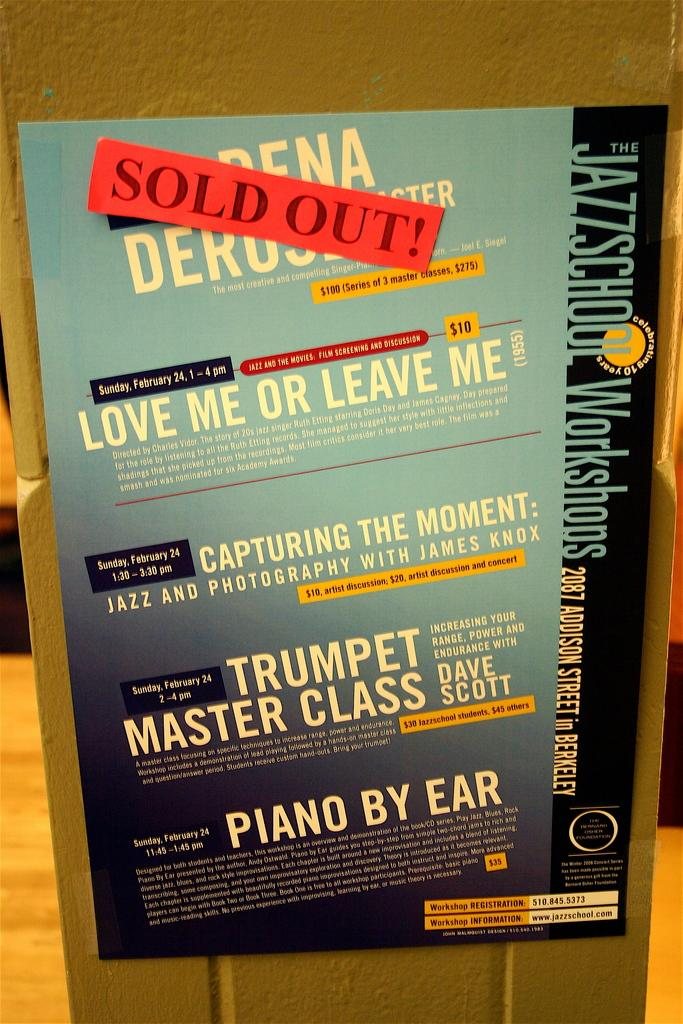<image>
Create a compact narrative representing the image presented. A red note pasted onto a poster says the event is sold out. 